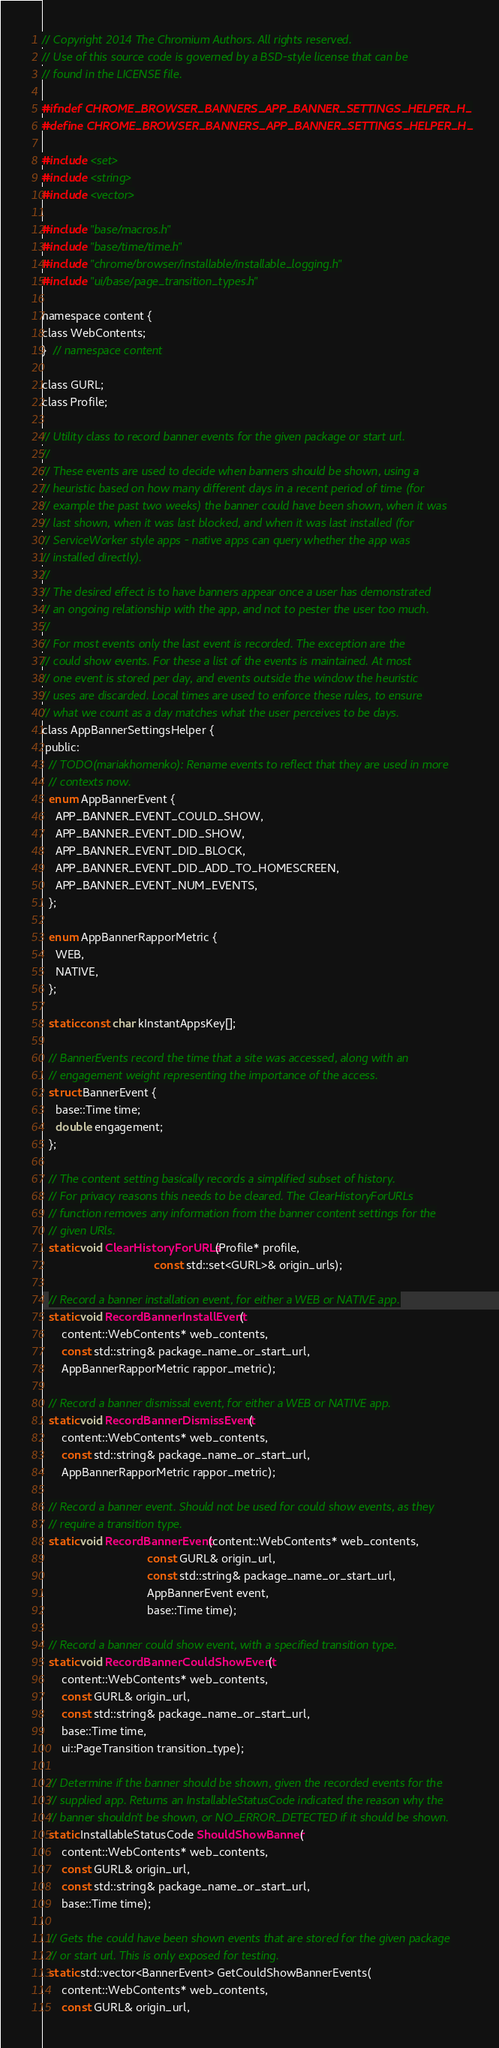Convert code to text. <code><loc_0><loc_0><loc_500><loc_500><_C_>// Copyright 2014 The Chromium Authors. All rights reserved.
// Use of this source code is governed by a BSD-style license that can be
// found in the LICENSE file.

#ifndef CHROME_BROWSER_BANNERS_APP_BANNER_SETTINGS_HELPER_H_
#define CHROME_BROWSER_BANNERS_APP_BANNER_SETTINGS_HELPER_H_

#include <set>
#include <string>
#include <vector>

#include "base/macros.h"
#include "base/time/time.h"
#include "chrome/browser/installable/installable_logging.h"
#include "ui/base/page_transition_types.h"

namespace content {
class WebContents;
}  // namespace content

class GURL;
class Profile;

// Utility class to record banner events for the given package or start url.
//
// These events are used to decide when banners should be shown, using a
// heuristic based on how many different days in a recent period of time (for
// example the past two weeks) the banner could have been shown, when it was
// last shown, when it was last blocked, and when it was last installed (for
// ServiceWorker style apps - native apps can query whether the app was
// installed directly).
//
// The desired effect is to have banners appear once a user has demonstrated
// an ongoing relationship with the app, and not to pester the user too much.
//
// For most events only the last event is recorded. The exception are the
// could show events. For these a list of the events is maintained. At most
// one event is stored per day, and events outside the window the heuristic
// uses are discarded. Local times are used to enforce these rules, to ensure
// what we count as a day matches what the user perceives to be days.
class AppBannerSettingsHelper {
 public:
  // TODO(mariakhomenko): Rename events to reflect that they are used in more
  // contexts now.
  enum AppBannerEvent {
    APP_BANNER_EVENT_COULD_SHOW,
    APP_BANNER_EVENT_DID_SHOW,
    APP_BANNER_EVENT_DID_BLOCK,
    APP_BANNER_EVENT_DID_ADD_TO_HOMESCREEN,
    APP_BANNER_EVENT_NUM_EVENTS,
  };

  enum AppBannerRapporMetric {
    WEB,
    NATIVE,
  };

  static const char kInstantAppsKey[];

  // BannerEvents record the time that a site was accessed, along with an
  // engagement weight representing the importance of the access.
  struct BannerEvent {
    base::Time time;
    double engagement;
  };

  // The content setting basically records a simplified subset of history.
  // For privacy reasons this needs to be cleared. The ClearHistoryForURLs
  // function removes any information from the banner content settings for the
  // given URls.
  static void ClearHistoryForURLs(Profile* profile,
                                  const std::set<GURL>& origin_urls);

  // Record a banner installation event, for either a WEB or NATIVE app.
  static void RecordBannerInstallEvent(
      content::WebContents* web_contents,
      const std::string& package_name_or_start_url,
      AppBannerRapporMetric rappor_metric);

  // Record a banner dismissal event, for either a WEB or NATIVE app.
  static void RecordBannerDismissEvent(
      content::WebContents* web_contents,
      const std::string& package_name_or_start_url,
      AppBannerRapporMetric rappor_metric);

  // Record a banner event. Should not be used for could show events, as they
  // require a transition type.
  static void RecordBannerEvent(content::WebContents* web_contents,
                                const GURL& origin_url,
                                const std::string& package_name_or_start_url,
                                AppBannerEvent event,
                                base::Time time);

  // Record a banner could show event, with a specified transition type.
  static void RecordBannerCouldShowEvent(
      content::WebContents* web_contents,
      const GURL& origin_url,
      const std::string& package_name_or_start_url,
      base::Time time,
      ui::PageTransition transition_type);

  // Determine if the banner should be shown, given the recorded events for the
  // supplied app. Returns an InstallableStatusCode indicated the reason why the
  // banner shouldn't be shown, or NO_ERROR_DETECTED if it should be shown.
  static InstallableStatusCode ShouldShowBanner(
      content::WebContents* web_contents,
      const GURL& origin_url,
      const std::string& package_name_or_start_url,
      base::Time time);

  // Gets the could have been shown events that are stored for the given package
  // or start url. This is only exposed for testing.
  static std::vector<BannerEvent> GetCouldShowBannerEvents(
      content::WebContents* web_contents,
      const GURL& origin_url,</code> 